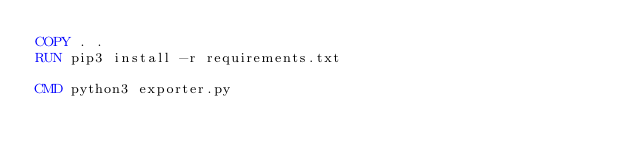Convert code to text. <code><loc_0><loc_0><loc_500><loc_500><_Dockerfile_>COPY . .
RUN pip3 install -r requirements.txt

CMD python3 exporter.py</code> 